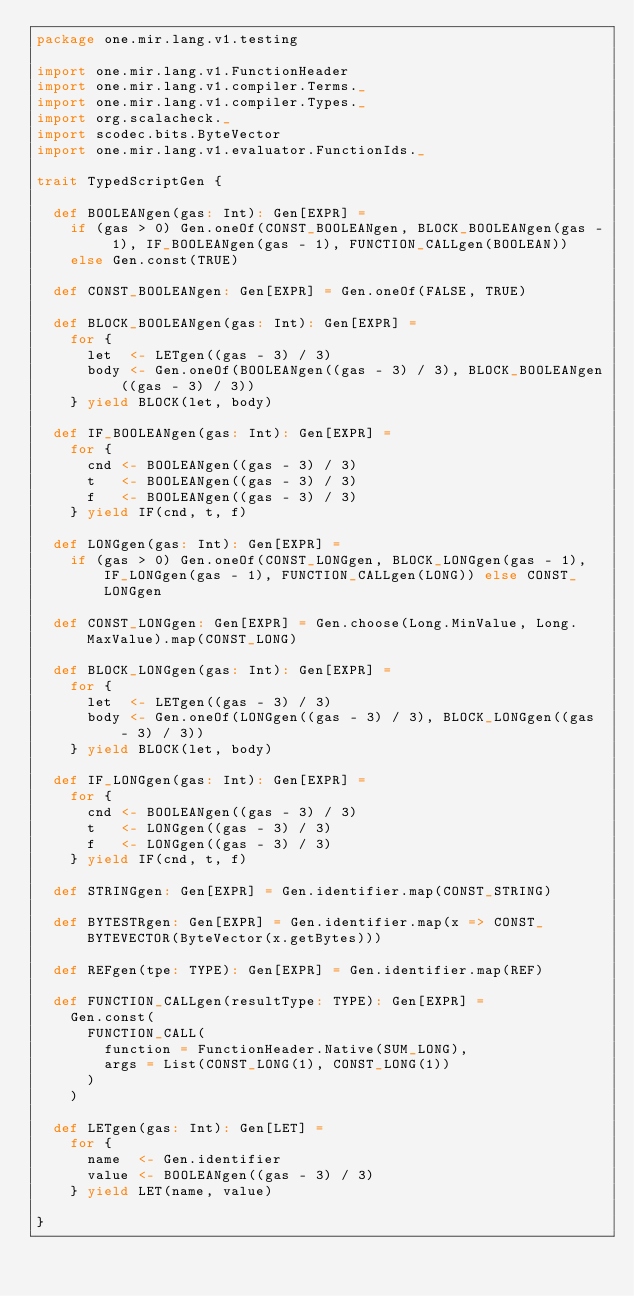Convert code to text. <code><loc_0><loc_0><loc_500><loc_500><_Scala_>package one.mir.lang.v1.testing

import one.mir.lang.v1.FunctionHeader
import one.mir.lang.v1.compiler.Terms._
import one.mir.lang.v1.compiler.Types._
import org.scalacheck._
import scodec.bits.ByteVector
import one.mir.lang.v1.evaluator.FunctionIds._

trait TypedScriptGen {

  def BOOLEANgen(gas: Int): Gen[EXPR] =
    if (gas > 0) Gen.oneOf(CONST_BOOLEANgen, BLOCK_BOOLEANgen(gas - 1), IF_BOOLEANgen(gas - 1), FUNCTION_CALLgen(BOOLEAN))
    else Gen.const(TRUE)

  def CONST_BOOLEANgen: Gen[EXPR] = Gen.oneOf(FALSE, TRUE)

  def BLOCK_BOOLEANgen(gas: Int): Gen[EXPR] =
    for {
      let  <- LETgen((gas - 3) / 3)
      body <- Gen.oneOf(BOOLEANgen((gas - 3) / 3), BLOCK_BOOLEANgen((gas - 3) / 3))
    } yield BLOCK(let, body)

  def IF_BOOLEANgen(gas: Int): Gen[EXPR] =
    for {
      cnd <- BOOLEANgen((gas - 3) / 3)
      t   <- BOOLEANgen((gas - 3) / 3)
      f   <- BOOLEANgen((gas - 3) / 3)
    } yield IF(cnd, t, f)

  def LONGgen(gas: Int): Gen[EXPR] =
    if (gas > 0) Gen.oneOf(CONST_LONGgen, BLOCK_LONGgen(gas - 1), IF_LONGgen(gas - 1), FUNCTION_CALLgen(LONG)) else CONST_LONGgen

  def CONST_LONGgen: Gen[EXPR] = Gen.choose(Long.MinValue, Long.MaxValue).map(CONST_LONG)

  def BLOCK_LONGgen(gas: Int): Gen[EXPR] =
    for {
      let  <- LETgen((gas - 3) / 3)
      body <- Gen.oneOf(LONGgen((gas - 3) / 3), BLOCK_LONGgen((gas - 3) / 3))
    } yield BLOCK(let, body)

  def IF_LONGgen(gas: Int): Gen[EXPR] =
    for {
      cnd <- BOOLEANgen((gas - 3) / 3)
      t   <- LONGgen((gas - 3) / 3)
      f   <- LONGgen((gas - 3) / 3)
    } yield IF(cnd, t, f)

  def STRINGgen: Gen[EXPR] = Gen.identifier.map(CONST_STRING)

  def BYTESTRgen: Gen[EXPR] = Gen.identifier.map(x => CONST_BYTEVECTOR(ByteVector(x.getBytes)))

  def REFgen(tpe: TYPE): Gen[EXPR] = Gen.identifier.map(REF)

  def FUNCTION_CALLgen(resultType: TYPE): Gen[EXPR] =
    Gen.const(
      FUNCTION_CALL(
        function = FunctionHeader.Native(SUM_LONG),
        args = List(CONST_LONG(1), CONST_LONG(1))
      )
    )

  def LETgen(gas: Int): Gen[LET] =
    for {
      name  <- Gen.identifier
      value <- BOOLEANgen((gas - 3) / 3)
    } yield LET(name, value)

}
</code> 